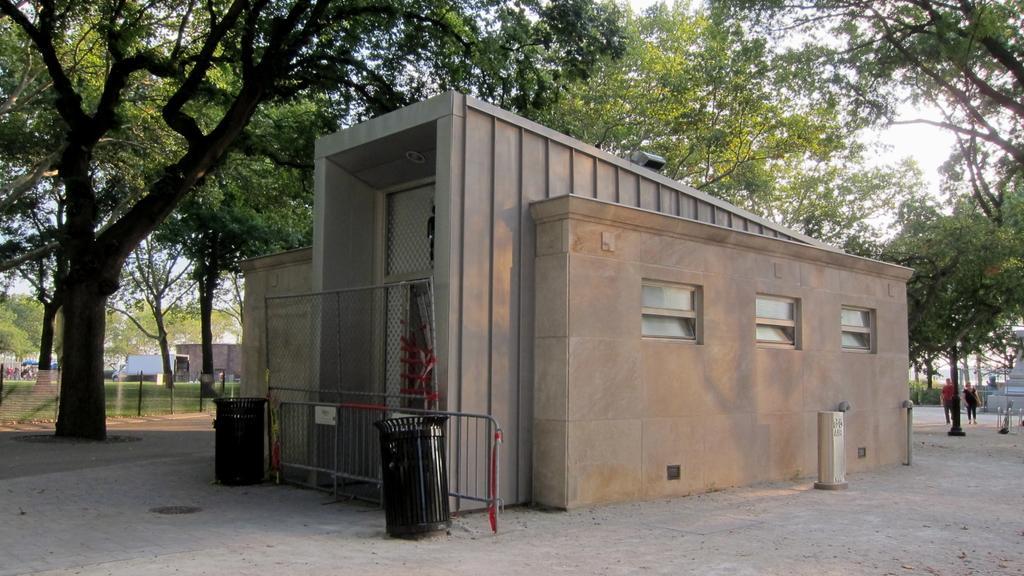How would you summarize this image in a sentence or two? In this image we can see trash cans, net, building, people walking here, fence, trees, tents, vehicle parked here and sky in the background. 